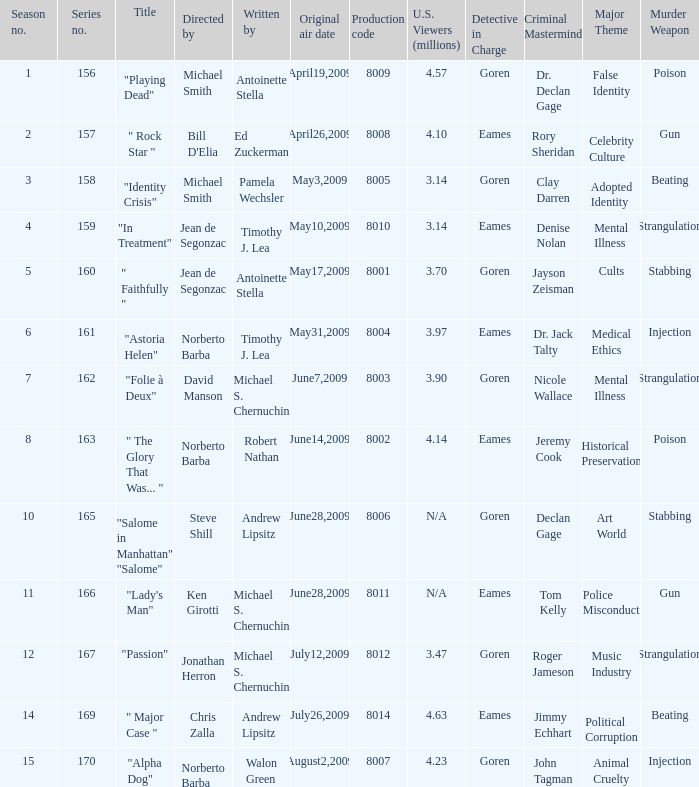What is the name of the episode whose writer is timothy j. lea and the director is norberto barba? "Astoria Helen". 